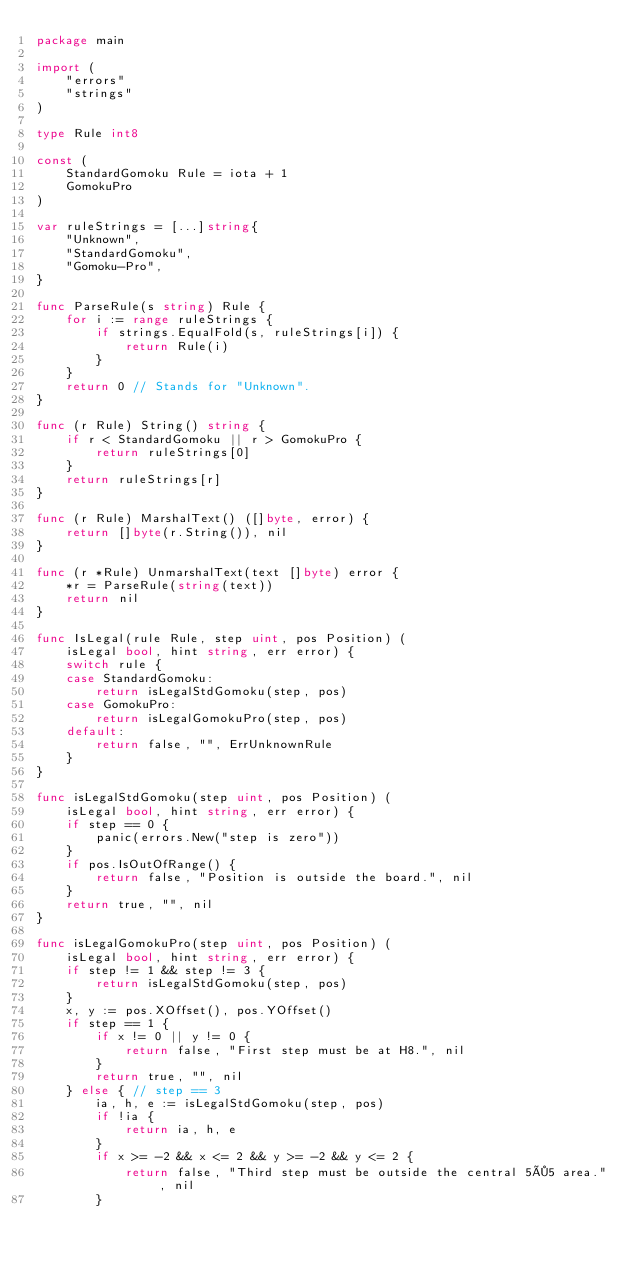<code> <loc_0><loc_0><loc_500><loc_500><_Go_>package main

import (
	"errors"
	"strings"
)

type Rule int8

const (
	StandardGomoku Rule = iota + 1
	GomokuPro
)

var ruleStrings = [...]string{
	"Unknown",
	"StandardGomoku",
	"Gomoku-Pro",
}

func ParseRule(s string) Rule {
	for i := range ruleStrings {
		if strings.EqualFold(s, ruleStrings[i]) {
			return Rule(i)
		}
	}
	return 0 // Stands for "Unknown".
}

func (r Rule) String() string {
	if r < StandardGomoku || r > GomokuPro {
		return ruleStrings[0]
	}
	return ruleStrings[r]
}

func (r Rule) MarshalText() ([]byte, error) {
	return []byte(r.String()), nil
}

func (r *Rule) UnmarshalText(text []byte) error {
	*r = ParseRule(string(text))
	return nil
}

func IsLegal(rule Rule, step uint, pos Position) (
	isLegal bool, hint string, err error) {
	switch rule {
	case StandardGomoku:
		return isLegalStdGomoku(step, pos)
	case GomokuPro:
		return isLegalGomokuPro(step, pos)
	default:
		return false, "", ErrUnknownRule
	}
}

func isLegalStdGomoku(step uint, pos Position) (
	isLegal bool, hint string, err error) {
	if step == 0 {
		panic(errors.New("step is zero"))
	}
	if pos.IsOutOfRange() {
		return false, "Position is outside the board.", nil
	}
	return true, "", nil
}

func isLegalGomokuPro(step uint, pos Position) (
	isLegal bool, hint string, err error) {
	if step != 1 && step != 3 {
		return isLegalStdGomoku(step, pos)
	}
	x, y := pos.XOffset(), pos.YOffset()
	if step == 1 {
		if x != 0 || y != 0 {
			return false, "First step must be at H8.", nil
		}
		return true, "", nil
	} else { // step == 3
		ia, h, e := isLegalStdGomoku(step, pos)
		if !ia {
			return ia, h, e
		}
		if x >= -2 && x <= 2 && y >= -2 && y <= 2 {
			return false, "Third step must be outside the central 5×5 area.", nil
		}</code> 